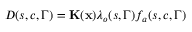<formula> <loc_0><loc_0><loc_500><loc_500>D ( s , c , \Gamma ) = { K } ( x ) { \lambda } _ { o } ( s , \Gamma ) f _ { a } ( s , c , \Gamma )</formula> 